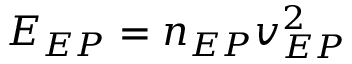<formula> <loc_0><loc_0><loc_500><loc_500>E _ { E P } = n _ { E P } v _ { E P } ^ { 2 }</formula> 